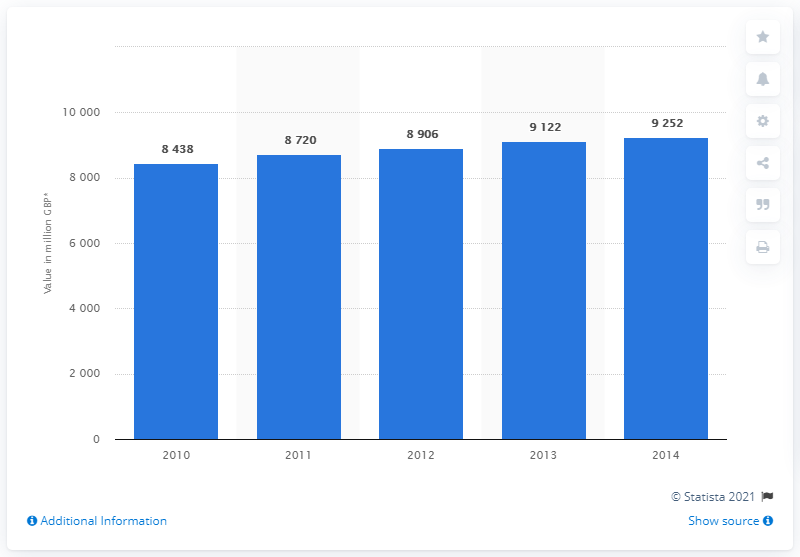Draw attention to some important aspects in this diagram. In 2014, the value of the UK soft drink market was approximately 9,252 million pounds. 